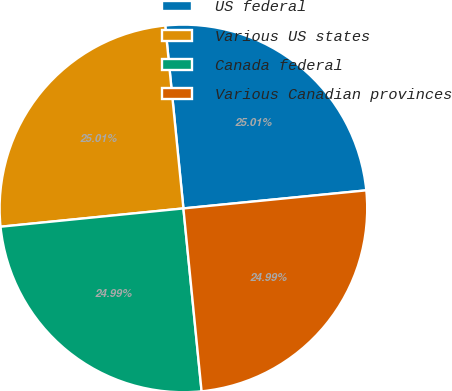Convert chart to OTSL. <chart><loc_0><loc_0><loc_500><loc_500><pie_chart><fcel>US federal<fcel>Various US states<fcel>Canada federal<fcel>Various Canadian provinces<nl><fcel>25.01%<fcel>25.01%<fcel>24.99%<fcel>24.99%<nl></chart> 